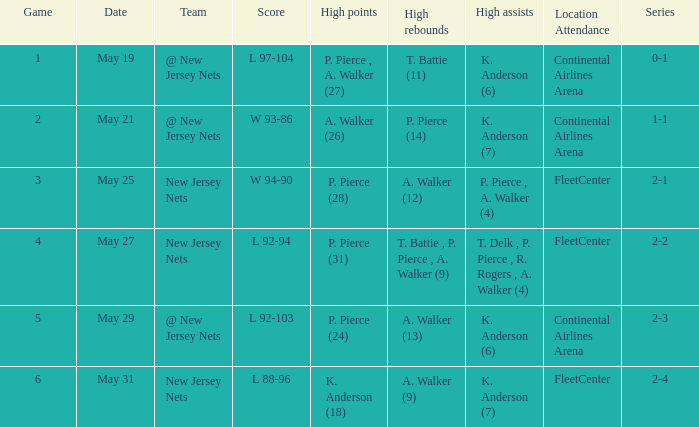What was the highest assists for game 3? P. Pierce , A. Walker (4). 